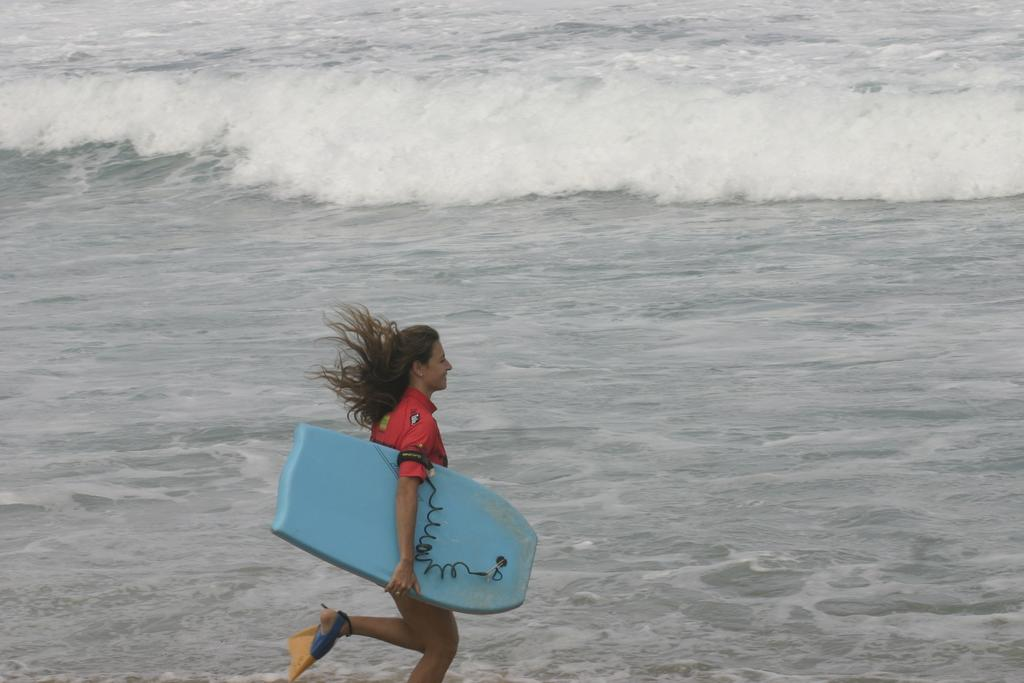Who is present in the image? There is a woman in the image. What is the woman holding in the image? The woman is holding a surfing board. What can be seen in the background of the image? The image depicts a sea. What type of blade is the woman using to cut the mitten in the image? There is no blade or mitten present in the image. The woman is holding a surfing board and standing near a sea. 